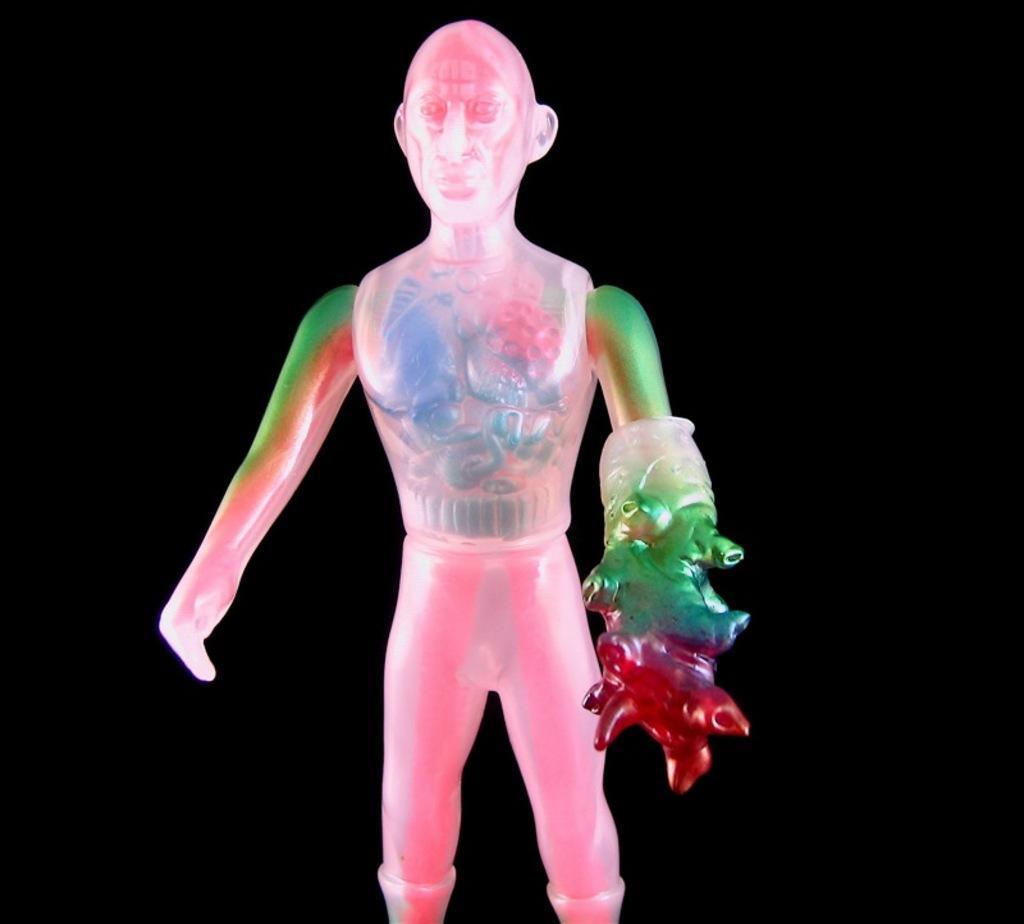Could you give a brief overview of what you see in this image? In this picture I can see there is a toy and it is in pink and green color and it has something to its left hand and the backdrop is dark. 